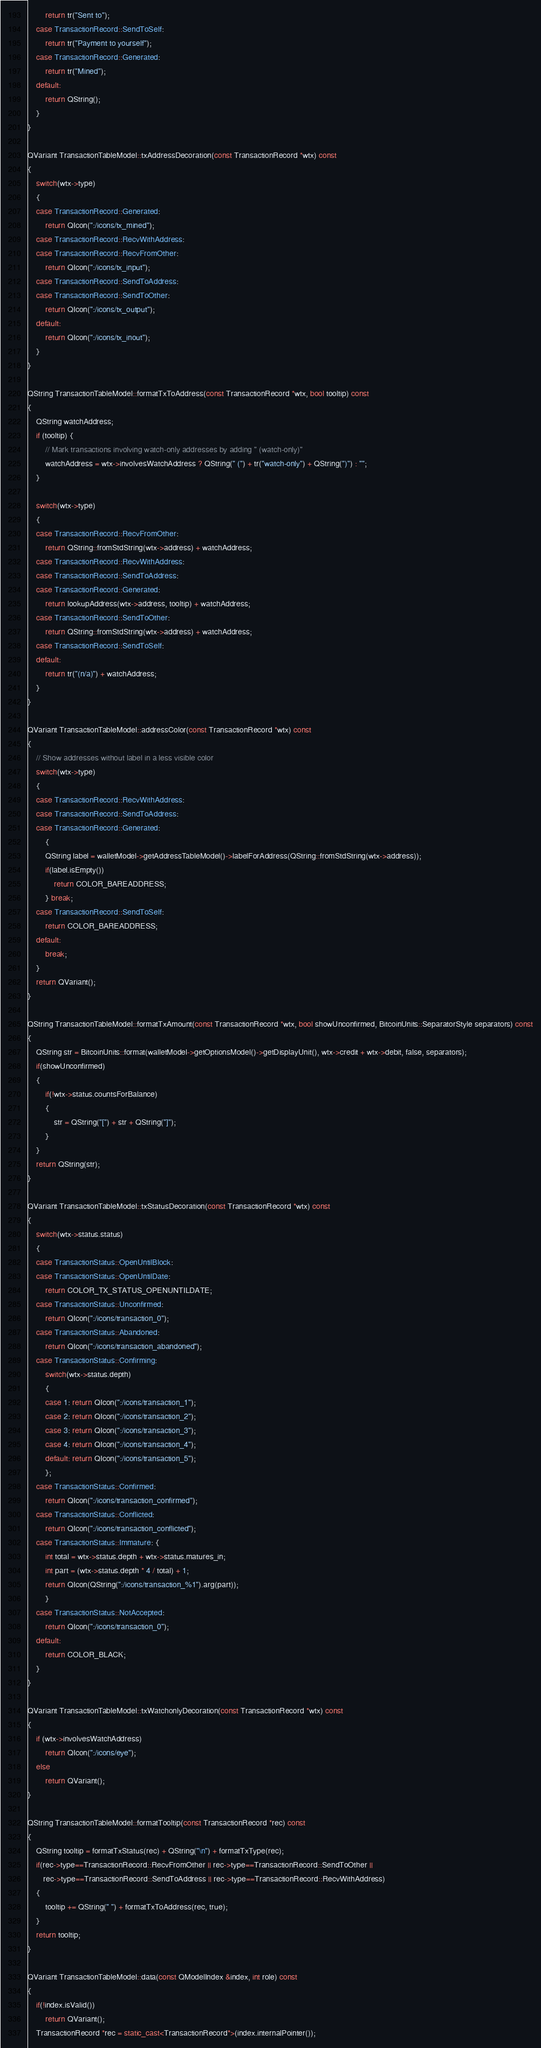Convert code to text. <code><loc_0><loc_0><loc_500><loc_500><_C++_>        return tr("Sent to");
    case TransactionRecord::SendToSelf:
        return tr("Payment to yourself");
    case TransactionRecord::Generated:
        return tr("Mined");
    default:
        return QString();
    }
}

QVariant TransactionTableModel::txAddressDecoration(const TransactionRecord *wtx) const
{
    switch(wtx->type)
    {
    case TransactionRecord::Generated:
        return QIcon(":/icons/tx_mined");
    case TransactionRecord::RecvWithAddress:
    case TransactionRecord::RecvFromOther:
        return QIcon(":/icons/tx_input");
    case TransactionRecord::SendToAddress:
    case TransactionRecord::SendToOther:
        return QIcon(":/icons/tx_output");
    default:
        return QIcon(":/icons/tx_inout");
    }
}

QString TransactionTableModel::formatTxToAddress(const TransactionRecord *wtx, bool tooltip) const
{
    QString watchAddress;
    if (tooltip) {
        // Mark transactions involving watch-only addresses by adding " (watch-only)"
        watchAddress = wtx->involvesWatchAddress ? QString(" (") + tr("watch-only") + QString(")") : "";
    }

    switch(wtx->type)
    {
    case TransactionRecord::RecvFromOther:
        return QString::fromStdString(wtx->address) + watchAddress;
    case TransactionRecord::RecvWithAddress:
    case TransactionRecord::SendToAddress:
    case TransactionRecord::Generated:
        return lookupAddress(wtx->address, tooltip) + watchAddress;
    case TransactionRecord::SendToOther:
        return QString::fromStdString(wtx->address) + watchAddress;
    case TransactionRecord::SendToSelf:
    default:
        return tr("(n/a)") + watchAddress;
    }
}

QVariant TransactionTableModel::addressColor(const TransactionRecord *wtx) const
{
    // Show addresses without label in a less visible color
    switch(wtx->type)
    {
    case TransactionRecord::RecvWithAddress:
    case TransactionRecord::SendToAddress:
    case TransactionRecord::Generated:
        {
        QString label = walletModel->getAddressTableModel()->labelForAddress(QString::fromStdString(wtx->address));
        if(label.isEmpty())
            return COLOR_BAREADDRESS;
        } break;
    case TransactionRecord::SendToSelf:
        return COLOR_BAREADDRESS;
    default:
        break;
    }
    return QVariant();
}

QString TransactionTableModel::formatTxAmount(const TransactionRecord *wtx, bool showUnconfirmed, BitcoinUnits::SeparatorStyle separators) const
{
    QString str = BitcoinUnits::format(walletModel->getOptionsModel()->getDisplayUnit(), wtx->credit + wtx->debit, false, separators);
    if(showUnconfirmed)
    {
        if(!wtx->status.countsForBalance)
        {
            str = QString("[") + str + QString("]");
        }
    }
    return QString(str);
}

QVariant TransactionTableModel::txStatusDecoration(const TransactionRecord *wtx) const
{
    switch(wtx->status.status)
    {
    case TransactionStatus::OpenUntilBlock:
    case TransactionStatus::OpenUntilDate:
        return COLOR_TX_STATUS_OPENUNTILDATE;
    case TransactionStatus::Unconfirmed:
        return QIcon(":/icons/transaction_0");
    case TransactionStatus::Abandoned:
        return QIcon(":/icons/transaction_abandoned");
    case TransactionStatus::Confirming:
        switch(wtx->status.depth)
        {
        case 1: return QIcon(":/icons/transaction_1");
        case 2: return QIcon(":/icons/transaction_2");
        case 3: return QIcon(":/icons/transaction_3");
        case 4: return QIcon(":/icons/transaction_4");
        default: return QIcon(":/icons/transaction_5");
        };
    case TransactionStatus::Confirmed:
        return QIcon(":/icons/transaction_confirmed");
    case TransactionStatus::Conflicted:
        return QIcon(":/icons/transaction_conflicted");
    case TransactionStatus::Immature: {
        int total = wtx->status.depth + wtx->status.matures_in;
        int part = (wtx->status.depth * 4 / total) + 1;
        return QIcon(QString(":/icons/transaction_%1").arg(part));
        }
    case TransactionStatus::NotAccepted:
        return QIcon(":/icons/transaction_0");
    default:
        return COLOR_BLACK;
    }
}

QVariant TransactionTableModel::txWatchonlyDecoration(const TransactionRecord *wtx) const
{
    if (wtx->involvesWatchAddress)
        return QIcon(":/icons/eye");
    else
        return QVariant();
}

QString TransactionTableModel::formatTooltip(const TransactionRecord *rec) const
{
    QString tooltip = formatTxStatus(rec) + QString("\n") + formatTxType(rec);
    if(rec->type==TransactionRecord::RecvFromOther || rec->type==TransactionRecord::SendToOther ||
       rec->type==TransactionRecord::SendToAddress || rec->type==TransactionRecord::RecvWithAddress)
    {
        tooltip += QString(" ") + formatTxToAddress(rec, true);
    }
    return tooltip;
}

QVariant TransactionTableModel::data(const QModelIndex &index, int role) const
{
    if(!index.isValid())
        return QVariant();
    TransactionRecord *rec = static_cast<TransactionRecord*>(index.internalPointer());
</code> 